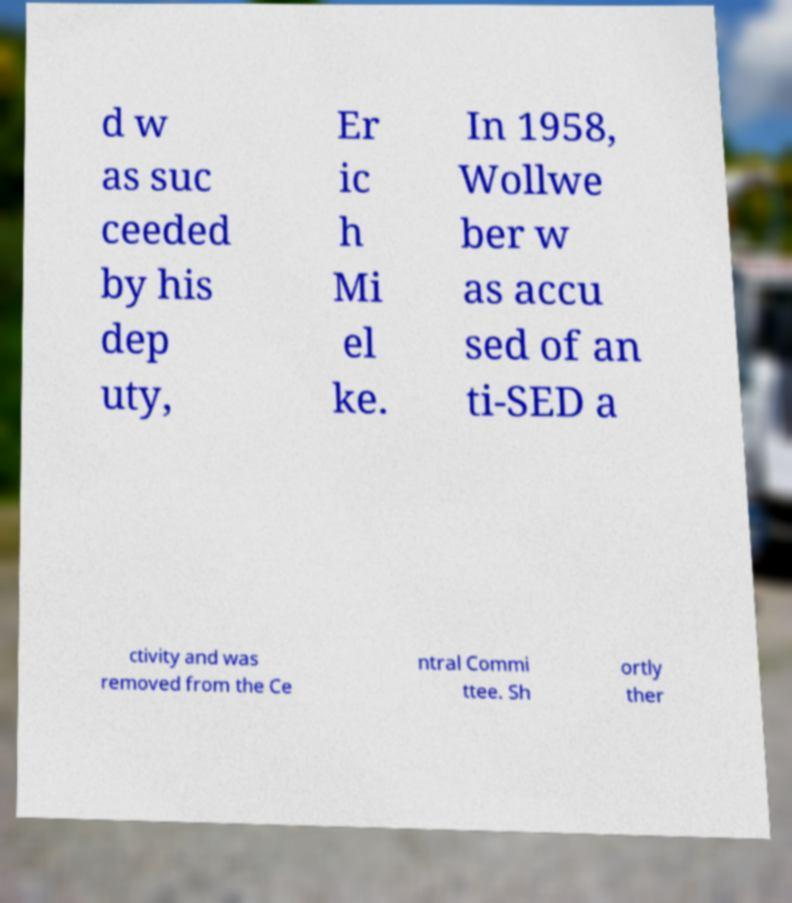There's text embedded in this image that I need extracted. Can you transcribe it verbatim? d w as suc ceeded by his dep uty, Er ic h Mi el ke. In 1958, Wollwe ber w as accu sed of an ti-SED a ctivity and was removed from the Ce ntral Commi ttee. Sh ortly ther 